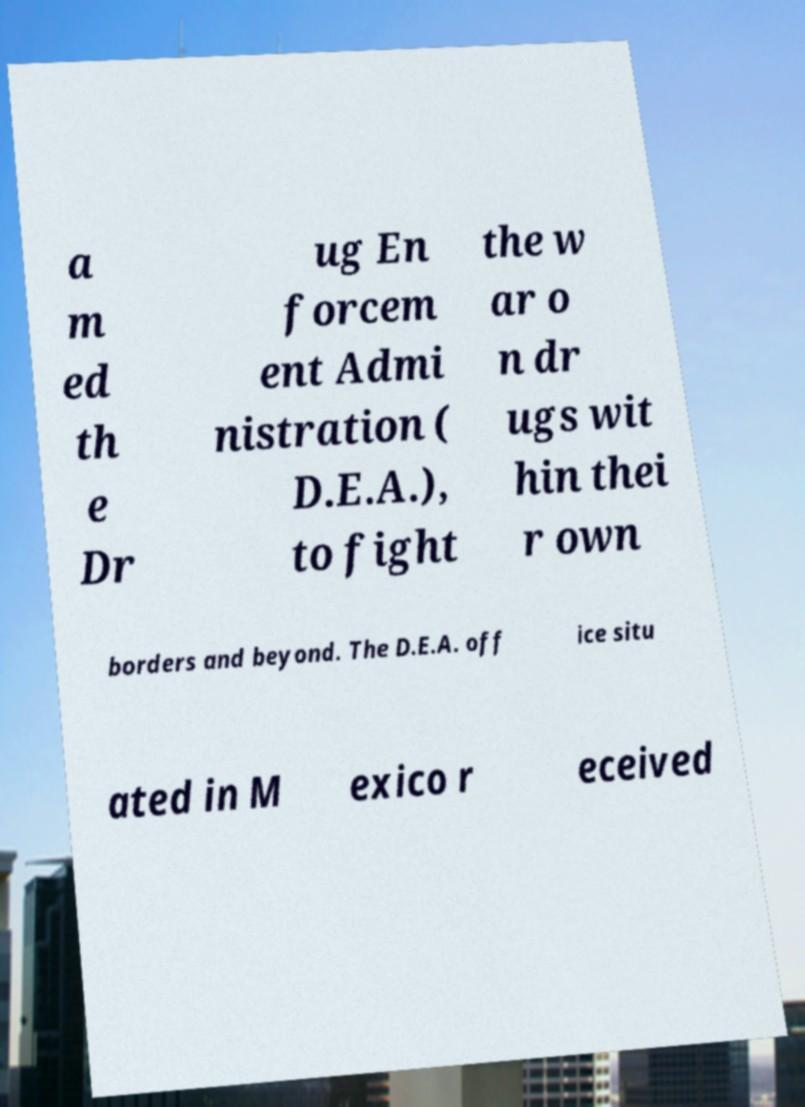For documentation purposes, I need the text within this image transcribed. Could you provide that? a m ed th e Dr ug En forcem ent Admi nistration ( D.E.A.), to fight the w ar o n dr ugs wit hin thei r own borders and beyond. The D.E.A. off ice situ ated in M exico r eceived 